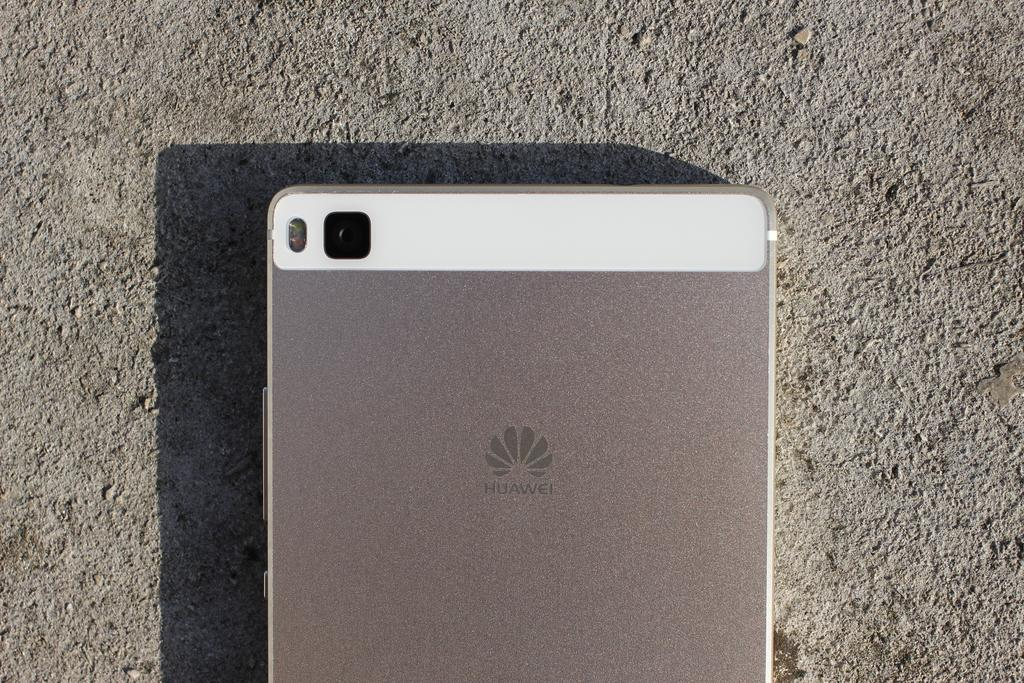<image>
Give a short and clear explanation of the subsequent image. A Huawei phone has a small square camera lens on the back of it. 